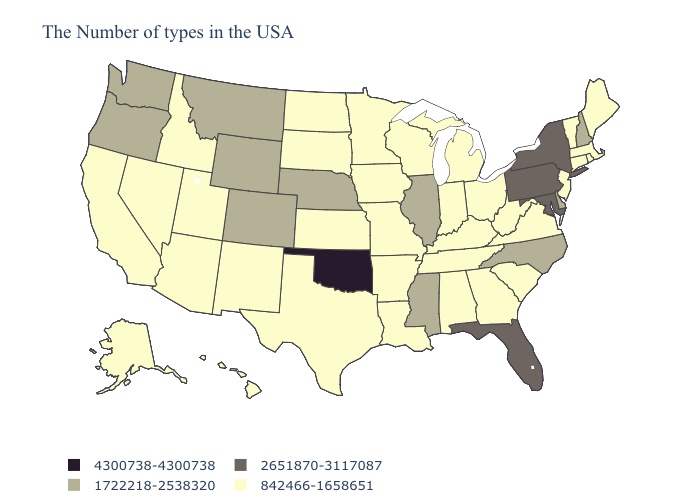Does Mississippi have the lowest value in the South?
Quick response, please. No. What is the value of Montana?
Be succinct. 1722218-2538320. What is the highest value in states that border Utah?
Concise answer only. 1722218-2538320. Does Wisconsin have the same value as Minnesota?
Short answer required. Yes. What is the value of Texas?
Quick response, please. 842466-1658651. Among the states that border Delaware , which have the lowest value?
Quick response, please. New Jersey. Which states hav the highest value in the South?
Answer briefly. Oklahoma. Does Minnesota have the highest value in the USA?
Write a very short answer. No. Name the states that have a value in the range 2651870-3117087?
Answer briefly. New York, Maryland, Pennsylvania, Florida. Does New York have a higher value than Wyoming?
Answer briefly. Yes. Name the states that have a value in the range 1722218-2538320?
Short answer required. New Hampshire, Delaware, North Carolina, Illinois, Mississippi, Nebraska, Wyoming, Colorado, Montana, Washington, Oregon. How many symbols are there in the legend?
Short answer required. 4. What is the highest value in states that border Nebraska?
Concise answer only. 1722218-2538320. Which states have the highest value in the USA?
Keep it brief. Oklahoma. Name the states that have a value in the range 2651870-3117087?
Give a very brief answer. New York, Maryland, Pennsylvania, Florida. 